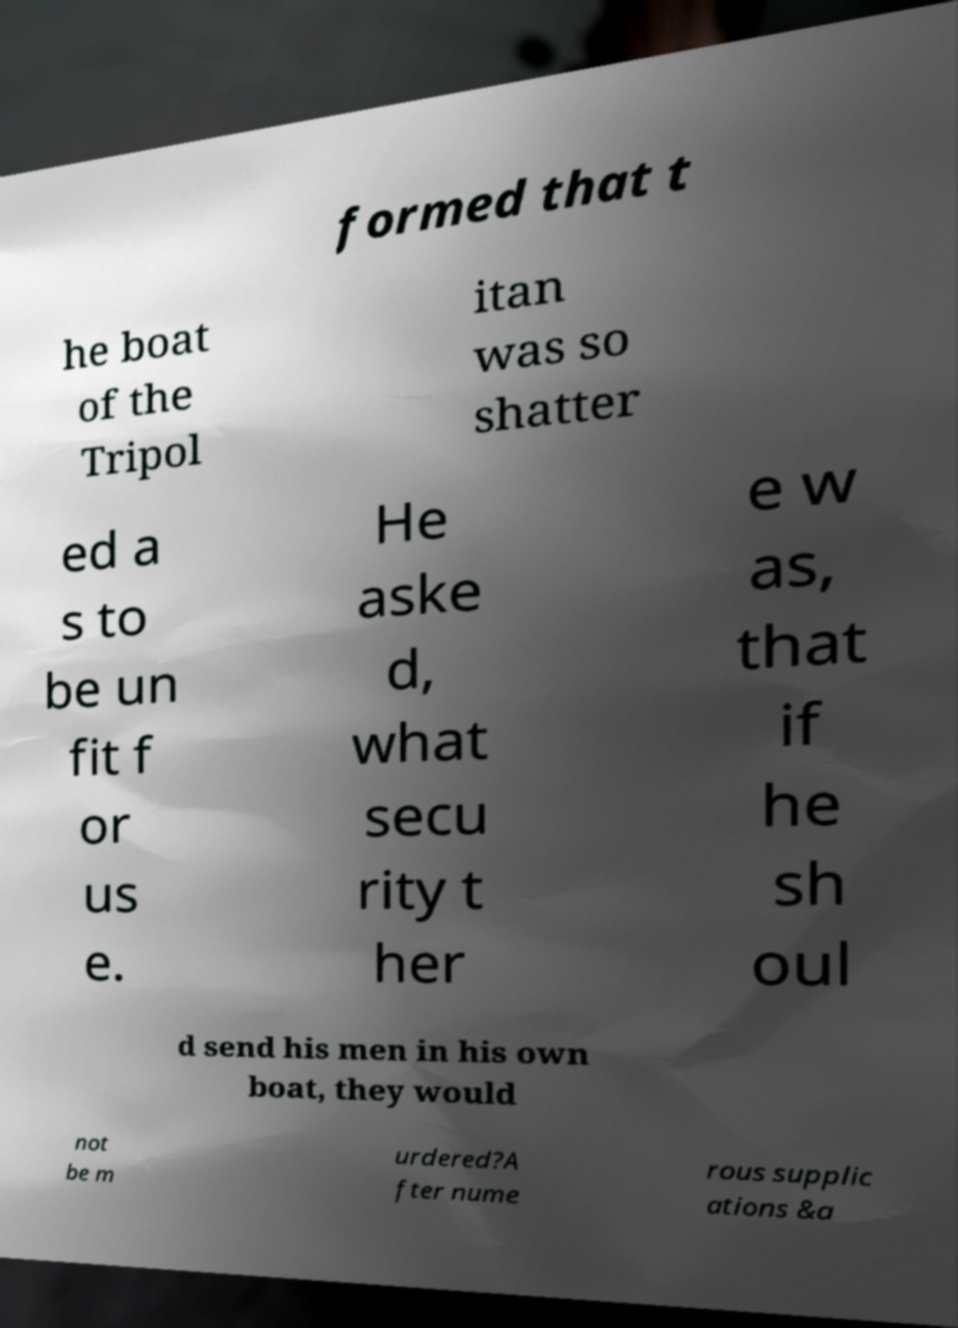What messages or text are displayed in this image? I need them in a readable, typed format. formed that t he boat of the Tripol itan was so shatter ed a s to be un fit f or us e. He aske d, what secu rity t her e w as, that if he sh oul d send his men in his own boat, they would not be m urdered?A fter nume rous supplic ations &a 